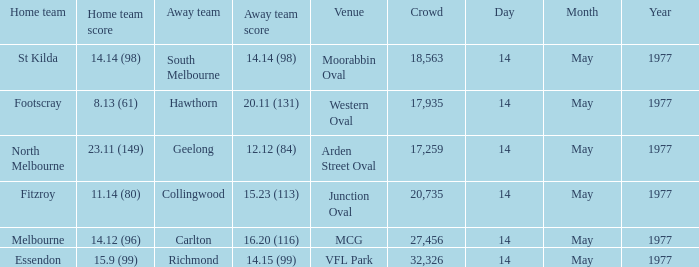How many people were in the crowd with the away team being collingwood? 1.0. 